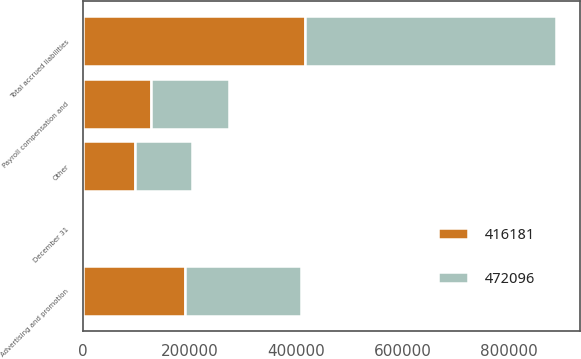Convert chart to OTSL. <chart><loc_0><loc_0><loc_500><loc_500><stacked_bar_chart><ecel><fcel>December 31<fcel>Payroll compensation and<fcel>Advertising and promotion<fcel>Other<fcel>Total accrued liabilities<nl><fcel>472096<fcel>2004<fcel>146515<fcel>218376<fcel>107205<fcel>472096<nl><fcel>416181<fcel>2003<fcel>127222<fcel>191382<fcel>97577<fcel>416181<nl></chart> 